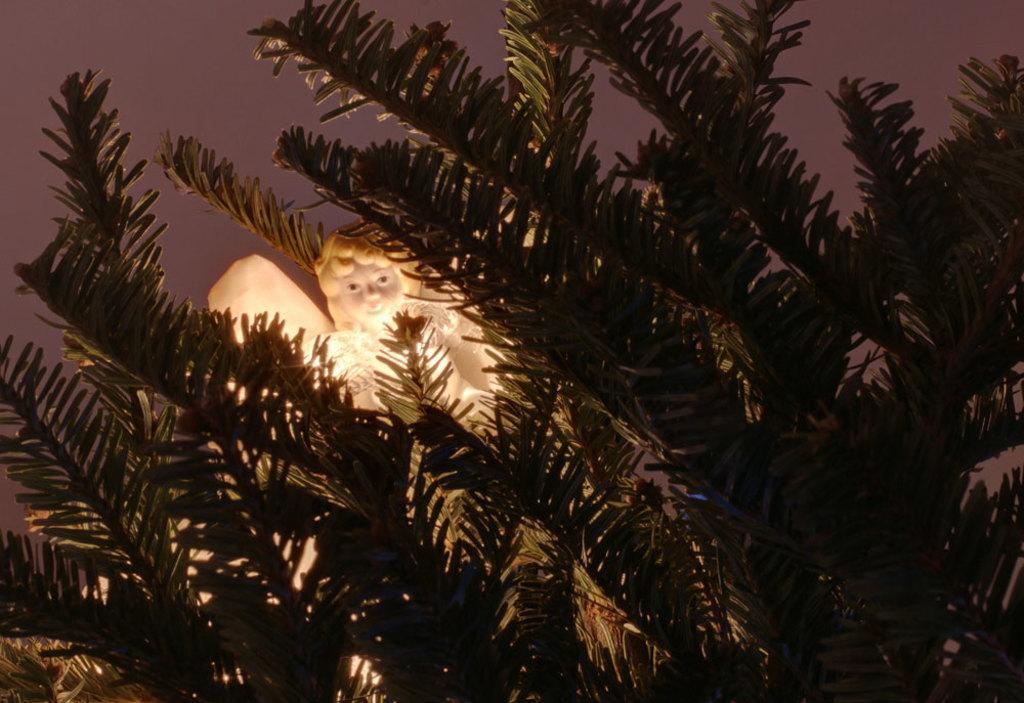Describe this image in one or two sentences. In this image I see a tree and a doll in between the leaves. 